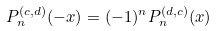<formula> <loc_0><loc_0><loc_500><loc_500>P _ { n } ^ { ( c , d ) } ( - x ) = ( - 1 ) ^ { n } P _ { n } ^ { ( d , c ) } ( x )</formula> 